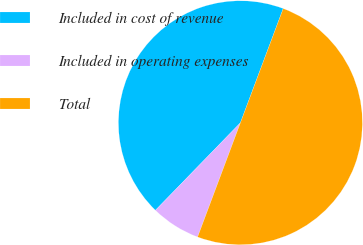Convert chart to OTSL. <chart><loc_0><loc_0><loc_500><loc_500><pie_chart><fcel>Included in cost of revenue<fcel>Included in operating expenses<fcel>Total<nl><fcel>43.44%<fcel>6.56%<fcel>50.0%<nl></chart> 